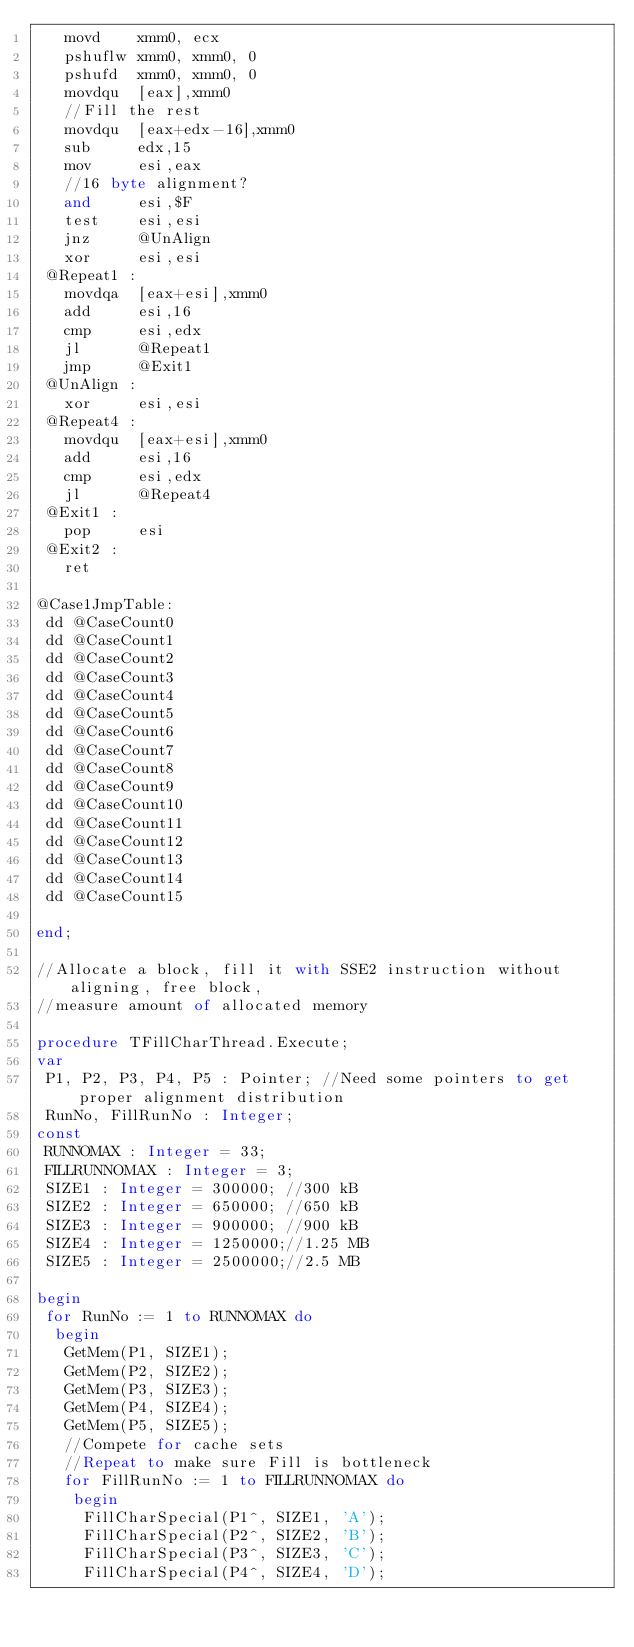<code> <loc_0><loc_0><loc_500><loc_500><_Pascal_>   movd    xmm0, ecx
   pshuflw xmm0, xmm0, 0
   pshufd  xmm0, xmm0, 0
   movdqu  [eax],xmm0
   //Fill the rest
   movdqu  [eax+edx-16],xmm0
   sub     edx,15
   mov     esi,eax
   //16 byte alignment?
   and     esi,$F
   test    esi,esi
   jnz     @UnAlign
   xor     esi,esi
 @Repeat1 :
   movdqa  [eax+esi],xmm0
   add     esi,16
   cmp     esi,edx
   jl      @Repeat1
   jmp     @Exit1
 @UnAlign :
   xor     esi,esi
 @Repeat4 :
   movdqu  [eax+esi],xmm0
   add     esi,16
   cmp     esi,edx
   jl      @Repeat4
 @Exit1 :
   pop     esi
 @Exit2 :
   ret

@Case1JmpTable:
 dd @CaseCount0
 dd @CaseCount1
 dd @CaseCount2
 dd @CaseCount3
 dd @CaseCount4
 dd @CaseCount5
 dd @CaseCount6
 dd @CaseCount7
 dd @CaseCount8
 dd @CaseCount9
 dd @CaseCount10
 dd @CaseCount11
 dd @CaseCount12
 dd @CaseCount13
 dd @CaseCount14
 dd @CaseCount15

end;

//Allocate a block, fill it with SSE2 instruction without aligning, free block,
//measure amount of allocated memory

procedure TFillCharThread.Execute;
var
 P1, P2, P3, P4, P5 : Pointer; //Need some pointers to get proper alignment distribution
 RunNo, FillRunNo : Integer;
const
 RUNNOMAX : Integer = 33;
 FILLRUNNOMAX : Integer = 3;
 SIZE1 : Integer = 300000; //300 kB
 SIZE2 : Integer = 650000; //650 kB
 SIZE3 : Integer = 900000; //900 kB
 SIZE4 : Integer = 1250000;//1.25 MB
 SIZE5 : Integer = 2500000;//2.5 MB

begin
 for RunNo := 1 to RUNNOMAX do
  begin
   GetMem(P1, SIZE1);
   GetMem(P2, SIZE2);
   GetMem(P3, SIZE3);
   GetMem(P4, SIZE4);
   GetMem(P5, SIZE5);
   //Compete for cache sets
   //Repeat to make sure Fill is bottleneck
   for FillRunNo := 1 to FILLRUNNOMAX do
    begin
     FillCharSpecial(P1^, SIZE1, 'A');
     FillCharSpecial(P2^, SIZE2, 'B');
     FillCharSpecial(P3^, SIZE3, 'C');
     FillCharSpecial(P4^, SIZE4, 'D');</code> 